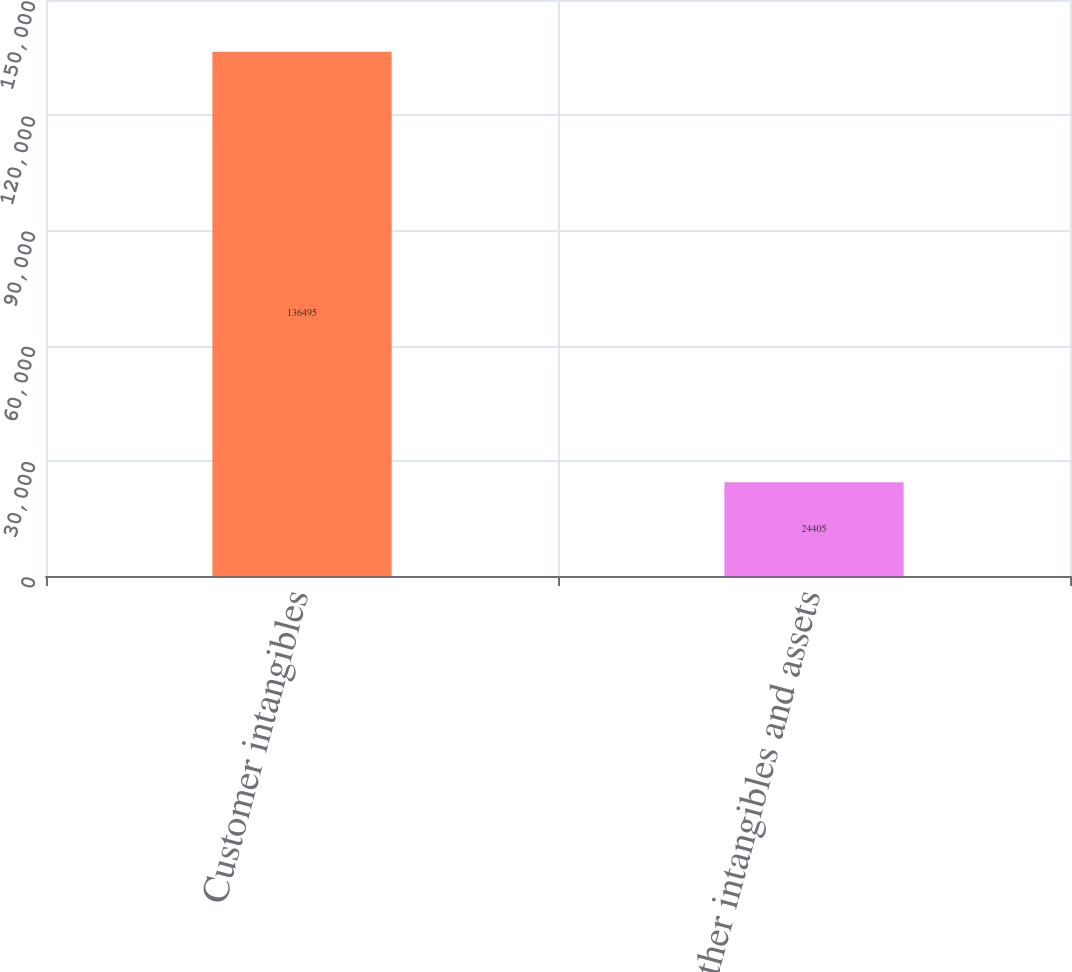Convert chart to OTSL. <chart><loc_0><loc_0><loc_500><loc_500><bar_chart><fcel>Customer intangibles<fcel>Other intangibles and assets<nl><fcel>136495<fcel>24405<nl></chart> 